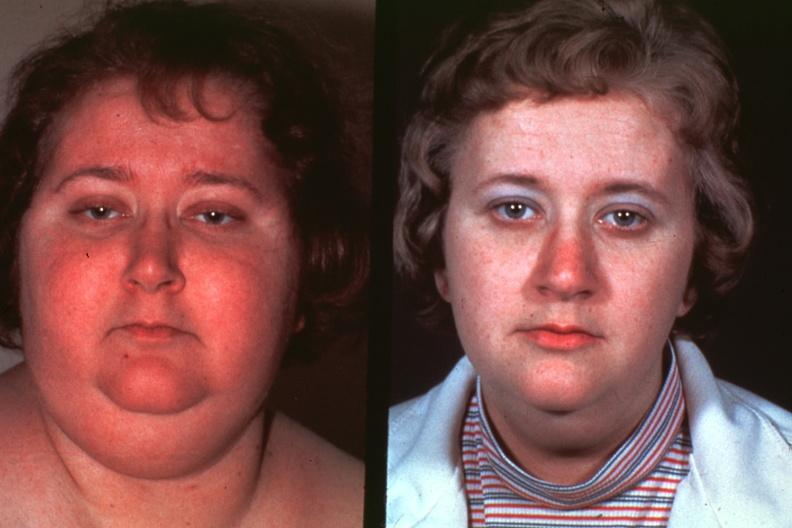when does this image show photos of lady?
Answer the question using a single word or phrase. Before disease and after excellent 